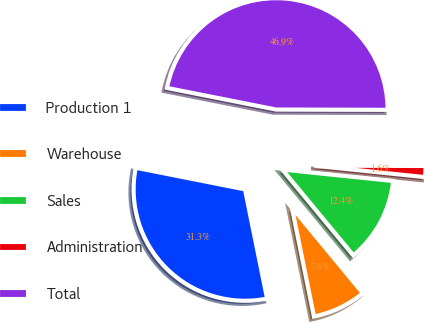Convert chart to OTSL. <chart><loc_0><loc_0><loc_500><loc_500><pie_chart><fcel>Production 1<fcel>Warehouse<fcel>Sales<fcel>Administration<fcel>Total<nl><fcel>31.29%<fcel>7.82%<fcel>12.36%<fcel>1.6%<fcel>46.93%<nl></chart> 